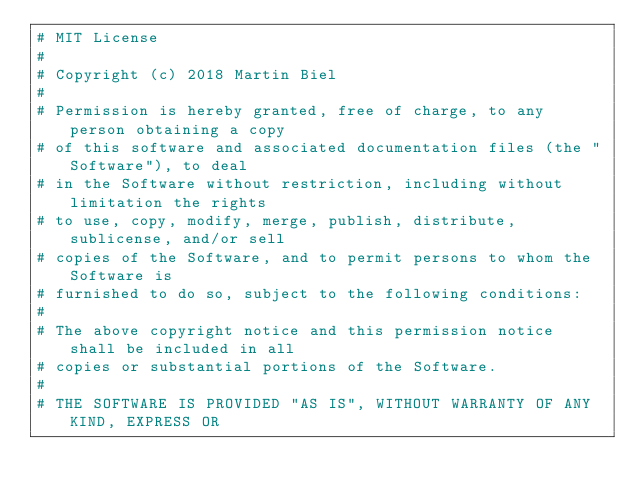Convert code to text. <code><loc_0><loc_0><loc_500><loc_500><_Julia_># MIT License
#
# Copyright (c) 2018 Martin Biel
#
# Permission is hereby granted, free of charge, to any person obtaining a copy
# of this software and associated documentation files (the "Software"), to deal
# in the Software without restriction, including without limitation the rights
# to use, copy, modify, merge, publish, distribute, sublicense, and/or sell
# copies of the Software, and to permit persons to whom the Software is
# furnished to do so, subject to the following conditions:
#
# The above copyright notice and this permission notice shall be included in all
# copies or substantial portions of the Software.
#
# THE SOFTWARE IS PROVIDED "AS IS", WITHOUT WARRANTY OF ANY KIND, EXPRESS OR</code> 